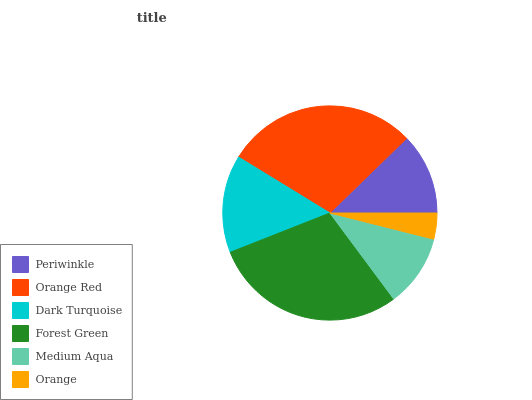Is Orange the minimum?
Answer yes or no. Yes. Is Forest Green the maximum?
Answer yes or no. Yes. Is Orange Red the minimum?
Answer yes or no. No. Is Orange Red the maximum?
Answer yes or no. No. Is Orange Red greater than Periwinkle?
Answer yes or no. Yes. Is Periwinkle less than Orange Red?
Answer yes or no. Yes. Is Periwinkle greater than Orange Red?
Answer yes or no. No. Is Orange Red less than Periwinkle?
Answer yes or no. No. Is Dark Turquoise the high median?
Answer yes or no. Yes. Is Periwinkle the low median?
Answer yes or no. Yes. Is Forest Green the high median?
Answer yes or no. No. Is Dark Turquoise the low median?
Answer yes or no. No. 